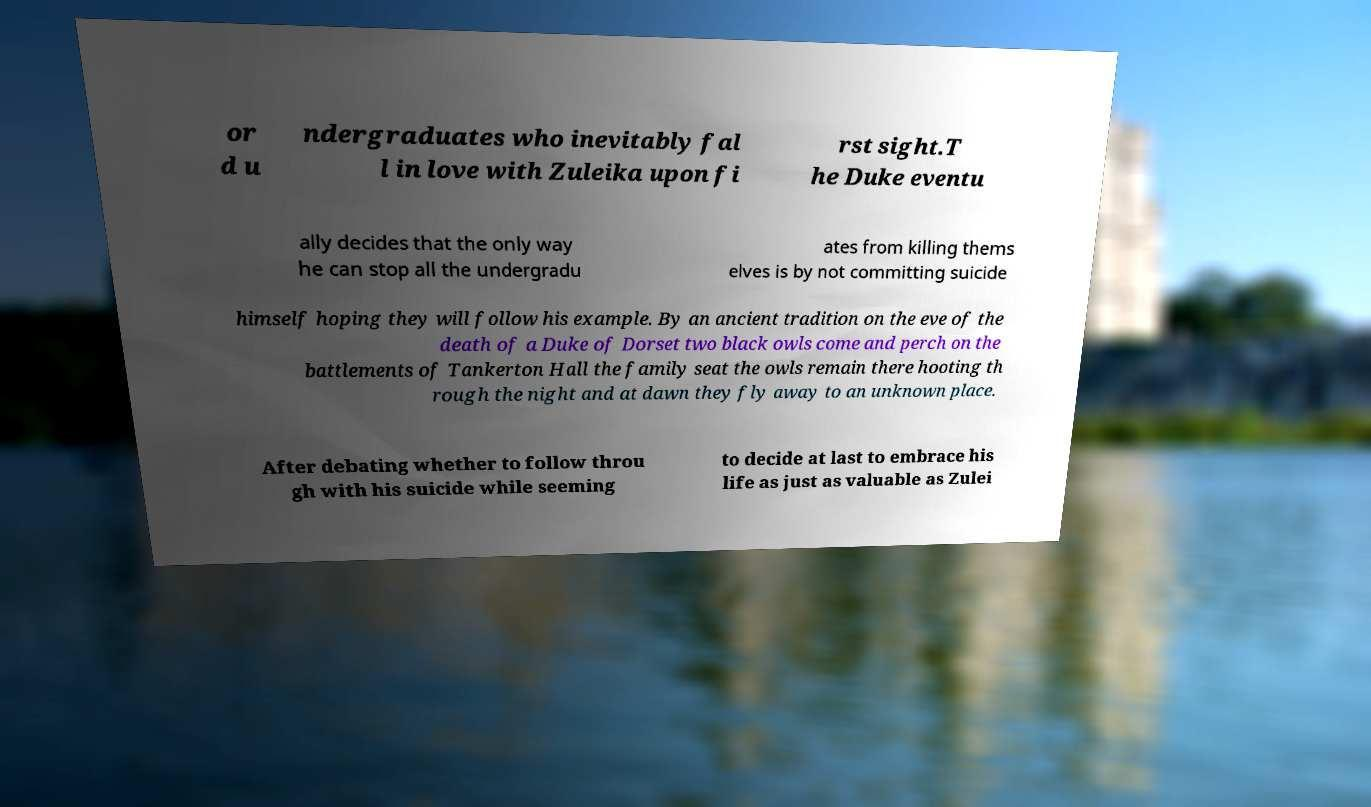Could you assist in decoding the text presented in this image and type it out clearly? or d u ndergraduates who inevitably fal l in love with Zuleika upon fi rst sight.T he Duke eventu ally decides that the only way he can stop all the undergradu ates from killing thems elves is by not committing suicide himself hoping they will follow his example. By an ancient tradition on the eve of the death of a Duke of Dorset two black owls come and perch on the battlements of Tankerton Hall the family seat the owls remain there hooting th rough the night and at dawn they fly away to an unknown place. After debating whether to follow throu gh with his suicide while seeming to decide at last to embrace his life as just as valuable as Zulei 